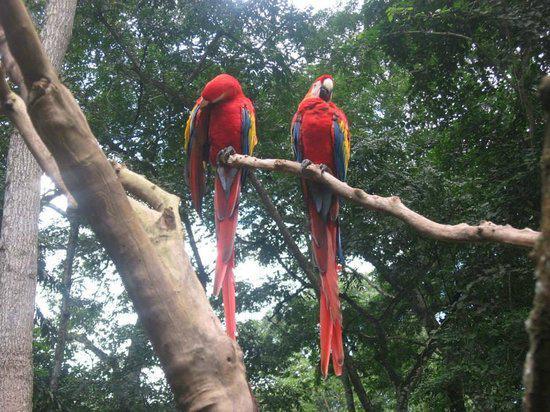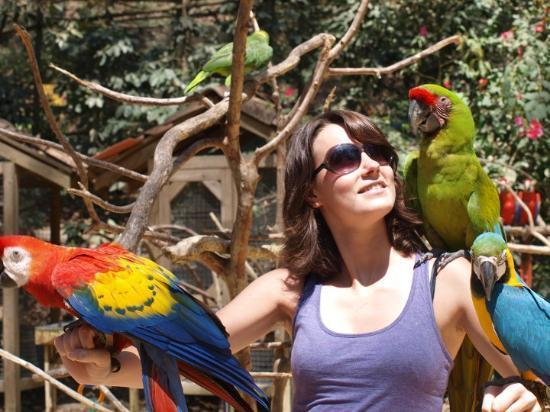The first image is the image on the left, the second image is the image on the right. Evaluate the accuracy of this statement regarding the images: "The image on the right contains only one parrot.". Is it true? Answer yes or no. No. The first image is the image on the left, the second image is the image on the right. Considering the images on both sides, is "One of the images contains parrots of different colors." valid? Answer yes or no. Yes. 